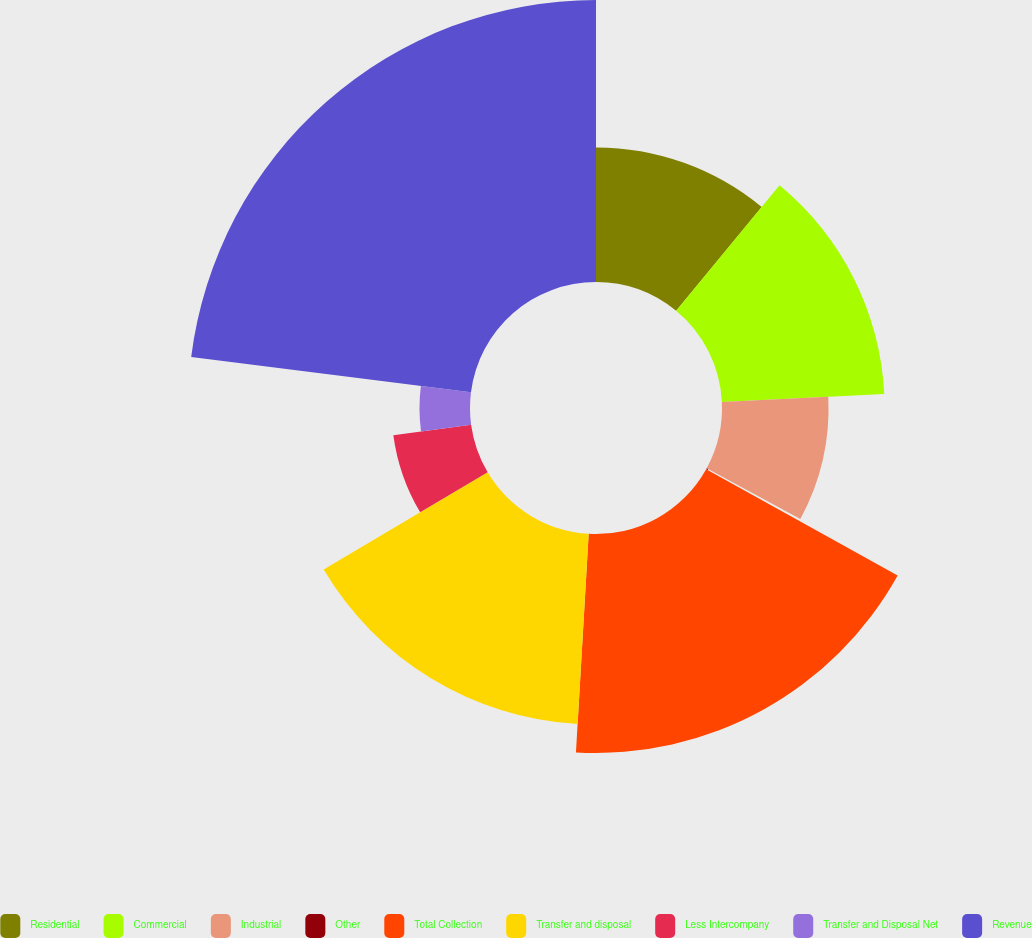Convert chart. <chart><loc_0><loc_0><loc_500><loc_500><pie_chart><fcel>Residential<fcel>Commercial<fcel>Industrial<fcel>Other<fcel>Total Collection<fcel>Transfer and disposal<fcel>Less Intercompany<fcel>Transfer and Disposal Net<fcel>Revenue<nl><fcel>10.97%<fcel>13.26%<fcel>8.69%<fcel>0.14%<fcel>17.86%<fcel>15.55%<fcel>6.4%<fcel>4.12%<fcel>23.0%<nl></chart> 